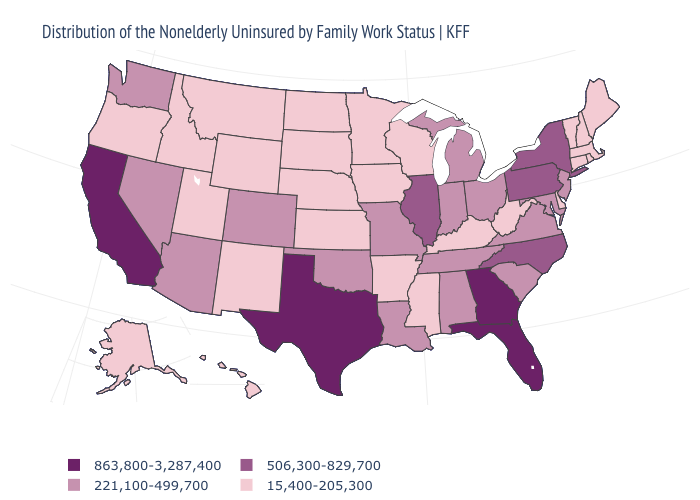What is the lowest value in the MidWest?
Short answer required. 15,400-205,300. What is the value of Kentucky?
Answer briefly. 15,400-205,300. What is the value of Kentucky?
Quick response, please. 15,400-205,300. Which states hav the highest value in the MidWest?
Give a very brief answer. Illinois. What is the lowest value in the MidWest?
Short answer required. 15,400-205,300. Name the states that have a value in the range 221,100-499,700?
Short answer required. Alabama, Arizona, Colorado, Indiana, Louisiana, Maryland, Michigan, Missouri, Nevada, New Jersey, Ohio, Oklahoma, South Carolina, Tennessee, Virginia, Washington. Name the states that have a value in the range 15,400-205,300?
Quick response, please. Alaska, Arkansas, Connecticut, Delaware, Hawaii, Idaho, Iowa, Kansas, Kentucky, Maine, Massachusetts, Minnesota, Mississippi, Montana, Nebraska, New Hampshire, New Mexico, North Dakota, Oregon, Rhode Island, South Dakota, Utah, Vermont, West Virginia, Wisconsin, Wyoming. What is the value of Maine?
Give a very brief answer. 15,400-205,300. Name the states that have a value in the range 15,400-205,300?
Quick response, please. Alaska, Arkansas, Connecticut, Delaware, Hawaii, Idaho, Iowa, Kansas, Kentucky, Maine, Massachusetts, Minnesota, Mississippi, Montana, Nebraska, New Hampshire, New Mexico, North Dakota, Oregon, Rhode Island, South Dakota, Utah, Vermont, West Virginia, Wisconsin, Wyoming. Among the states that border Massachusetts , does New York have the lowest value?
Be succinct. No. Name the states that have a value in the range 221,100-499,700?
Be succinct. Alabama, Arizona, Colorado, Indiana, Louisiana, Maryland, Michigan, Missouri, Nevada, New Jersey, Ohio, Oklahoma, South Carolina, Tennessee, Virginia, Washington. Among the states that border Colorado , does Kansas have the lowest value?
Quick response, please. Yes. Among the states that border New Hampshire , which have the lowest value?
Short answer required. Maine, Massachusetts, Vermont. Does Hawaii have the highest value in the USA?
Write a very short answer. No. Does South Dakota have the same value as North Dakota?
Answer briefly. Yes. 